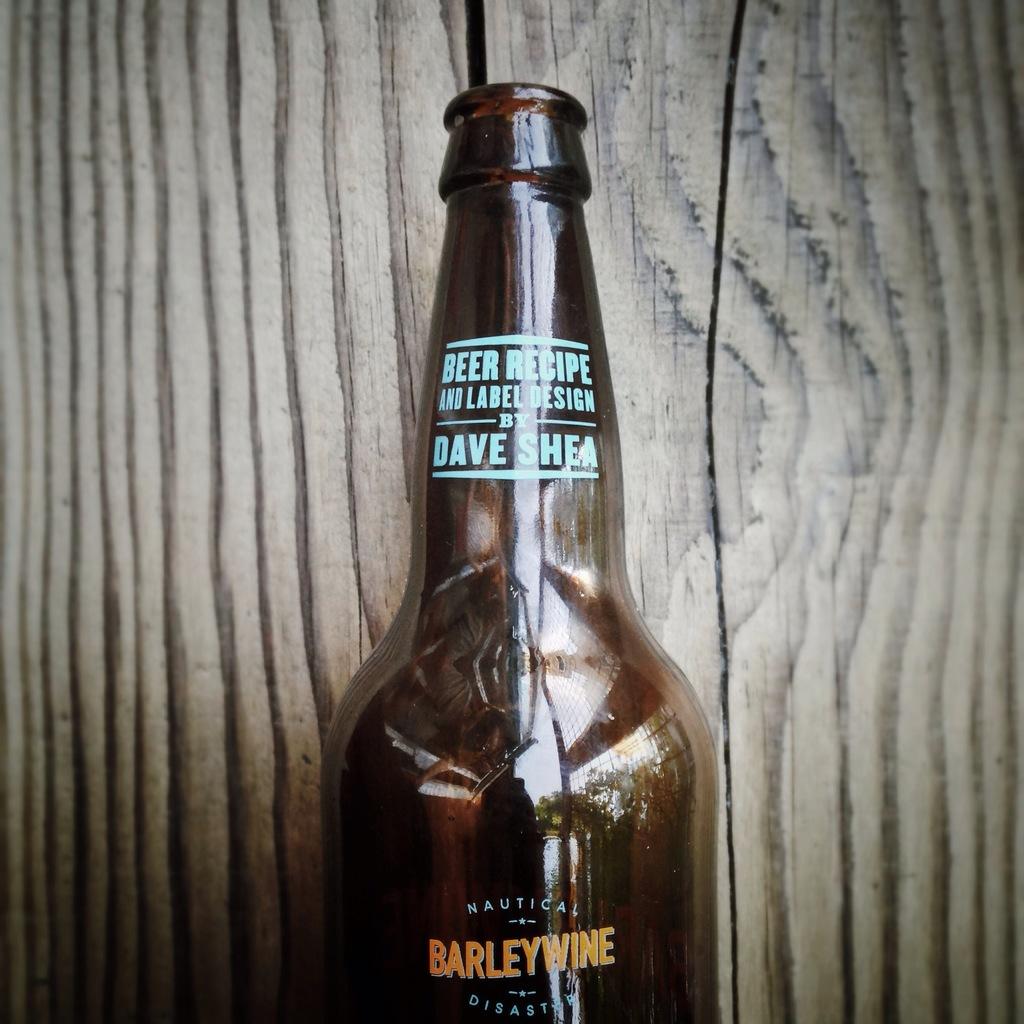What product is in the bottle?
Your response must be concise. Beer. 